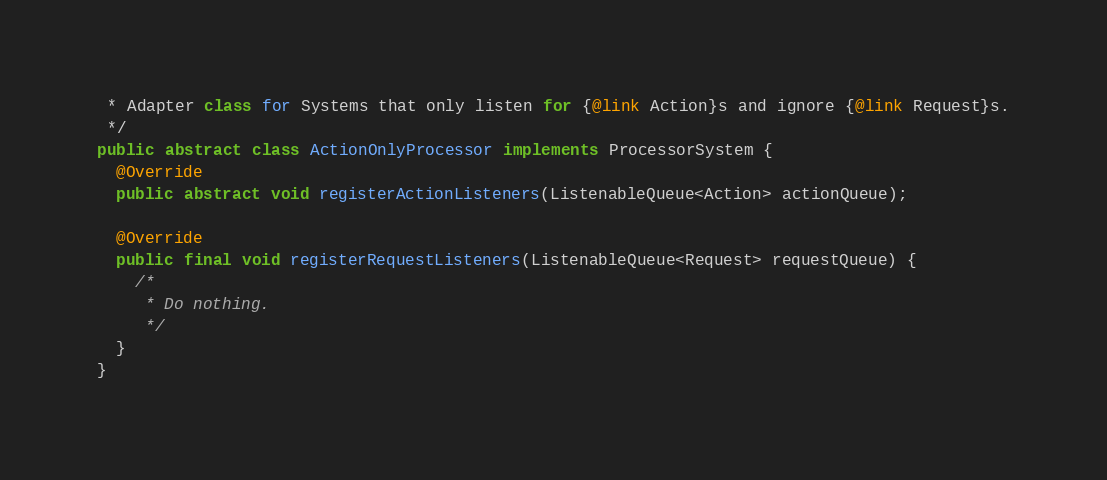Convert code to text. <code><loc_0><loc_0><loc_500><loc_500><_Java_> * Adapter class for Systems that only listen for {@link Action}s and ignore {@link Request}s.
 */
public abstract class ActionOnlyProcessor implements ProcessorSystem {
  @Override
  public abstract void registerActionListeners(ListenableQueue<Action> actionQueue);

  @Override
  public final void registerRequestListeners(ListenableQueue<Request> requestQueue) {
    /*
     * Do nothing.
     */
  }
}
</code> 